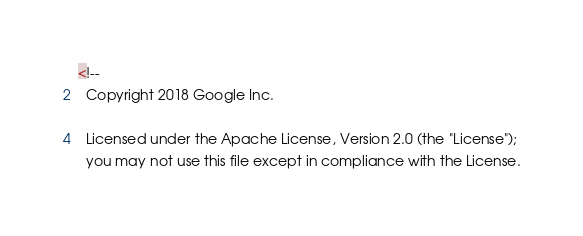<code> <loc_0><loc_0><loc_500><loc_500><_XML_><!--
  Copyright 2018 Google Inc.

  Licensed under the Apache License, Version 2.0 (the "License");
  you may not use this file except in compliance with the License.</code> 